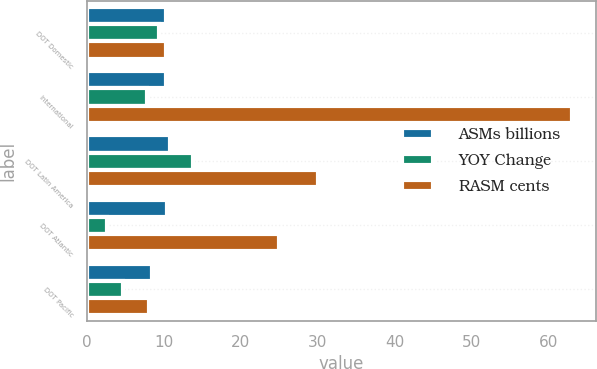Convert chart. <chart><loc_0><loc_0><loc_500><loc_500><stacked_bar_chart><ecel><fcel>DOT Domestic<fcel>International<fcel>DOT Latin America<fcel>DOT Atlantic<fcel>DOT Pacific<nl><fcel>ASMs billions<fcel>10.24<fcel>10.3<fcel>10.78<fcel>10.34<fcel>8.49<nl><fcel>YOY Change<fcel>9.3<fcel>7.8<fcel>13.7<fcel>2.6<fcel>4.6<nl><fcel>RASM cents<fcel>10.27<fcel>63<fcel>30<fcel>25<fcel>8<nl></chart> 